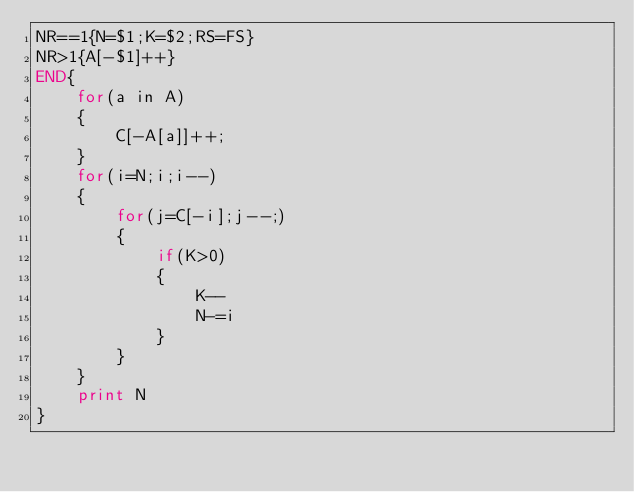<code> <loc_0><loc_0><loc_500><loc_500><_Awk_>NR==1{N=$1;K=$2;RS=FS}
NR>1{A[-$1]++}
END{
	for(a in A)
	{
		C[-A[a]]++;
	}
	for(i=N;i;i--)
	{
		for(j=C[-i];j--;)
		{
			if(K>0)
			{
				K--
				N-=i
			}
		}
	}
	print N
}
</code> 